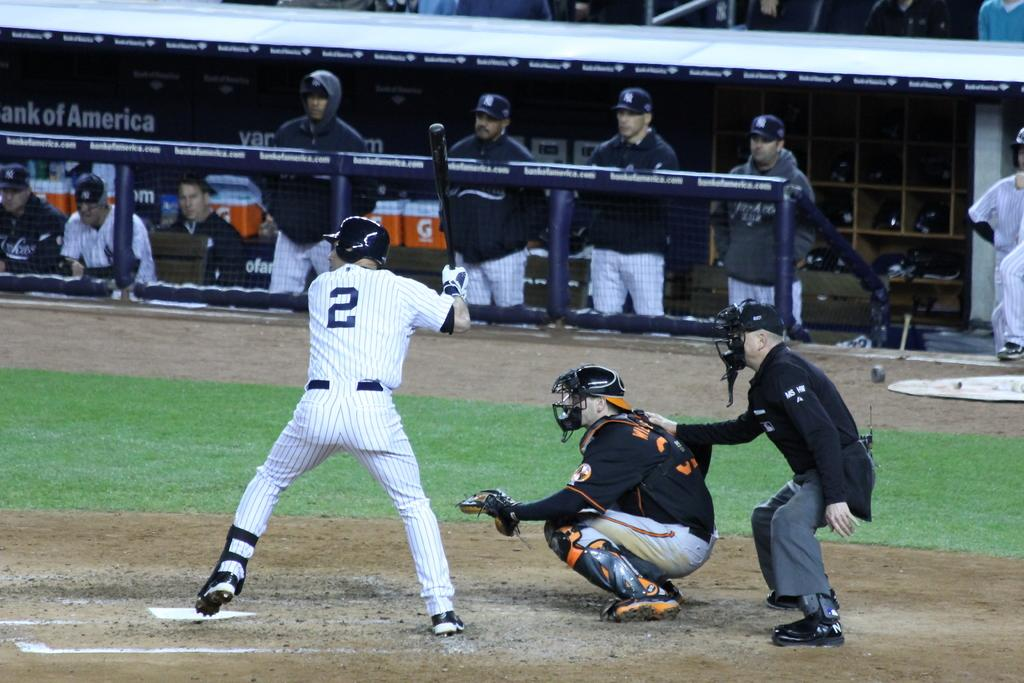<image>
Present a compact description of the photo's key features. Number 2 from the Yankees waits for a pitch against the Orioles. 